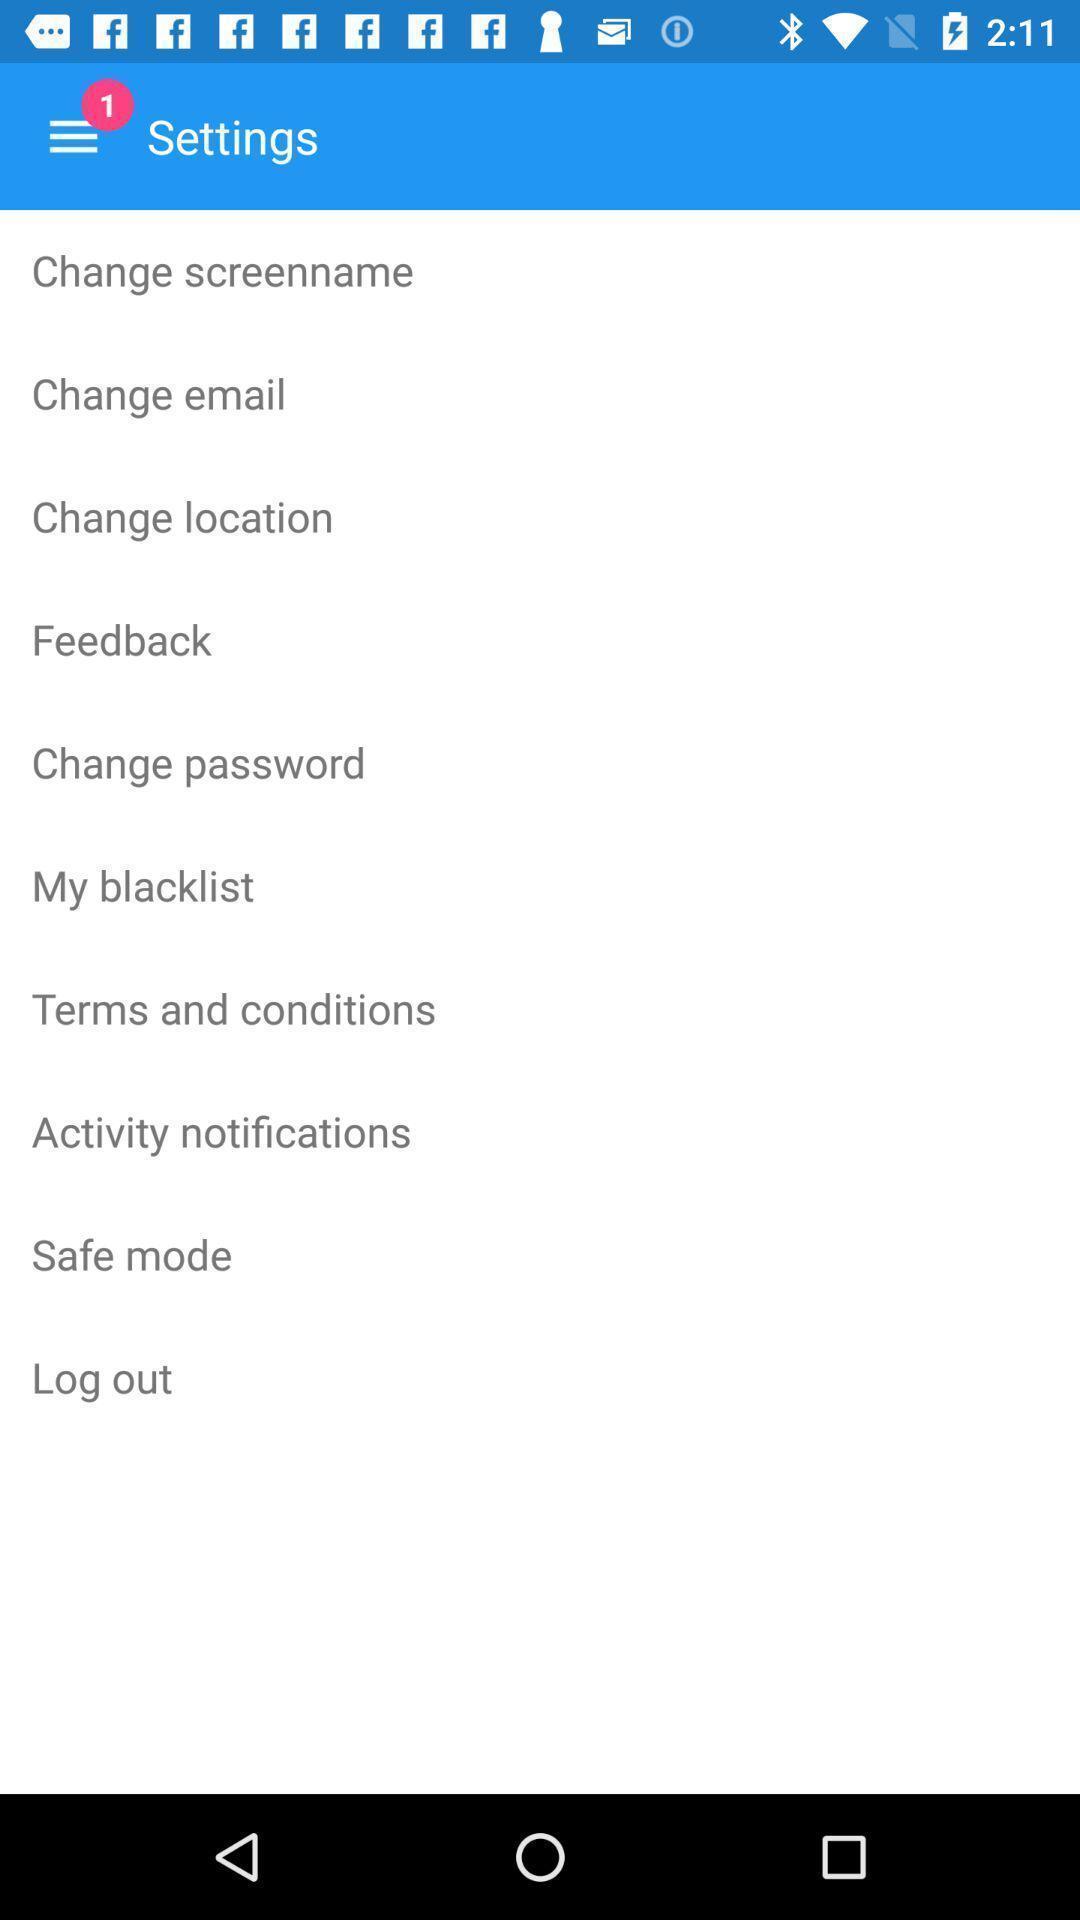Please provide a description for this image. Settings page showing list of options. 